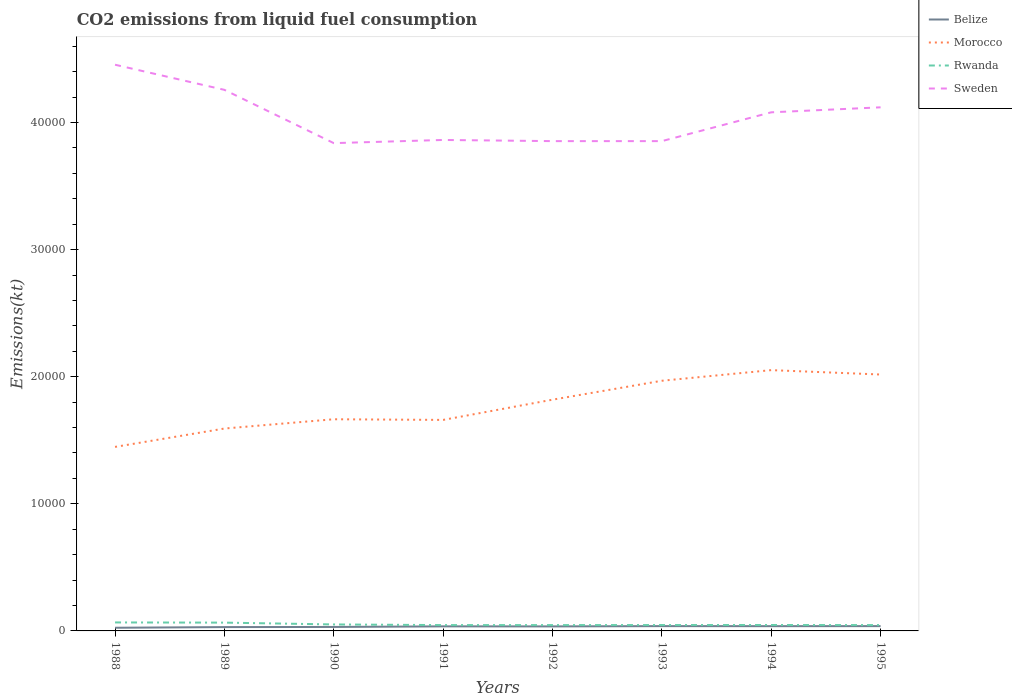How many different coloured lines are there?
Keep it short and to the point. 4. Is the number of lines equal to the number of legend labels?
Offer a very short reply. Yes. Across all years, what is the maximum amount of CO2 emitted in Morocco?
Give a very brief answer. 1.45e+04. In which year was the amount of CO2 emitted in Belize maximum?
Offer a very short reply. 1988. What is the total amount of CO2 emitted in Belize in the graph?
Keep it short and to the point. -11. What is the difference between the highest and the second highest amount of CO2 emitted in Sweden?
Ensure brevity in your answer.  6167.89. Is the amount of CO2 emitted in Morocco strictly greater than the amount of CO2 emitted in Rwanda over the years?
Offer a very short reply. No. How many lines are there?
Offer a very short reply. 4. How many years are there in the graph?
Keep it short and to the point. 8. Are the values on the major ticks of Y-axis written in scientific E-notation?
Offer a very short reply. No. Does the graph contain grids?
Ensure brevity in your answer.  No. Where does the legend appear in the graph?
Your answer should be very brief. Top right. What is the title of the graph?
Ensure brevity in your answer.  CO2 emissions from liquid fuel consumption. What is the label or title of the X-axis?
Provide a succinct answer. Years. What is the label or title of the Y-axis?
Keep it short and to the point. Emissions(kt). What is the Emissions(kt) in Belize in 1988?
Keep it short and to the point. 249.36. What is the Emissions(kt) in Morocco in 1988?
Keep it short and to the point. 1.45e+04. What is the Emissions(kt) of Rwanda in 1988?
Offer a very short reply. 667.39. What is the Emissions(kt) in Sweden in 1988?
Provide a short and direct response. 4.45e+04. What is the Emissions(kt) of Belize in 1989?
Your answer should be very brief. 300.69. What is the Emissions(kt) in Morocco in 1989?
Offer a very short reply. 1.59e+04. What is the Emissions(kt) of Rwanda in 1989?
Offer a very short reply. 652.73. What is the Emissions(kt) of Sweden in 1989?
Give a very brief answer. 4.26e+04. What is the Emissions(kt) in Belize in 1990?
Your answer should be compact. 311.69. What is the Emissions(kt) of Morocco in 1990?
Give a very brief answer. 1.67e+04. What is the Emissions(kt) of Rwanda in 1990?
Your response must be concise. 509.71. What is the Emissions(kt) in Sweden in 1990?
Make the answer very short. 3.84e+04. What is the Emissions(kt) in Belize in 1991?
Your answer should be compact. 359.37. What is the Emissions(kt) of Morocco in 1991?
Give a very brief answer. 1.66e+04. What is the Emissions(kt) of Rwanda in 1991?
Give a very brief answer. 458.38. What is the Emissions(kt) in Sweden in 1991?
Make the answer very short. 3.86e+04. What is the Emissions(kt) in Belize in 1992?
Give a very brief answer. 355.7. What is the Emissions(kt) in Morocco in 1992?
Your response must be concise. 1.82e+04. What is the Emissions(kt) in Rwanda in 1992?
Make the answer very short. 458.38. What is the Emissions(kt) of Sweden in 1992?
Your response must be concise. 3.85e+04. What is the Emissions(kt) in Belize in 1993?
Your answer should be very brief. 377.7. What is the Emissions(kt) of Morocco in 1993?
Give a very brief answer. 1.97e+04. What is the Emissions(kt) of Rwanda in 1993?
Offer a very short reply. 462.04. What is the Emissions(kt) of Sweden in 1993?
Keep it short and to the point. 3.85e+04. What is the Emissions(kt) in Belize in 1994?
Keep it short and to the point. 374.03. What is the Emissions(kt) in Morocco in 1994?
Your answer should be very brief. 2.05e+04. What is the Emissions(kt) in Rwanda in 1994?
Keep it short and to the point. 465.71. What is the Emissions(kt) in Sweden in 1994?
Ensure brevity in your answer.  4.08e+04. What is the Emissions(kt) in Belize in 1995?
Provide a short and direct response. 377.7. What is the Emissions(kt) in Morocco in 1995?
Your answer should be compact. 2.02e+04. What is the Emissions(kt) of Rwanda in 1995?
Offer a very short reply. 458.38. What is the Emissions(kt) of Sweden in 1995?
Offer a terse response. 4.12e+04. Across all years, what is the maximum Emissions(kt) of Belize?
Your answer should be compact. 377.7. Across all years, what is the maximum Emissions(kt) of Morocco?
Give a very brief answer. 2.05e+04. Across all years, what is the maximum Emissions(kt) in Rwanda?
Provide a succinct answer. 667.39. Across all years, what is the maximum Emissions(kt) in Sweden?
Keep it short and to the point. 4.45e+04. Across all years, what is the minimum Emissions(kt) in Belize?
Offer a terse response. 249.36. Across all years, what is the minimum Emissions(kt) in Morocco?
Make the answer very short. 1.45e+04. Across all years, what is the minimum Emissions(kt) of Rwanda?
Your answer should be very brief. 458.38. Across all years, what is the minimum Emissions(kt) in Sweden?
Keep it short and to the point. 3.84e+04. What is the total Emissions(kt) of Belize in the graph?
Make the answer very short. 2706.25. What is the total Emissions(kt) of Morocco in the graph?
Your answer should be compact. 1.42e+05. What is the total Emissions(kt) of Rwanda in the graph?
Keep it short and to the point. 4132.71. What is the total Emissions(kt) of Sweden in the graph?
Offer a very short reply. 3.23e+05. What is the difference between the Emissions(kt) of Belize in 1988 and that in 1989?
Keep it short and to the point. -51.34. What is the difference between the Emissions(kt) in Morocco in 1988 and that in 1989?
Provide a succinct answer. -1444.8. What is the difference between the Emissions(kt) of Rwanda in 1988 and that in 1989?
Give a very brief answer. 14.67. What is the difference between the Emissions(kt) in Sweden in 1988 and that in 1989?
Provide a succinct answer. 1976.51. What is the difference between the Emissions(kt) of Belize in 1988 and that in 1990?
Keep it short and to the point. -62.34. What is the difference between the Emissions(kt) of Morocco in 1988 and that in 1990?
Make the answer very short. -2174.53. What is the difference between the Emissions(kt) of Rwanda in 1988 and that in 1990?
Offer a very short reply. 157.68. What is the difference between the Emissions(kt) of Sweden in 1988 and that in 1990?
Offer a very short reply. 6167.89. What is the difference between the Emissions(kt) of Belize in 1988 and that in 1991?
Keep it short and to the point. -110.01. What is the difference between the Emissions(kt) in Morocco in 1988 and that in 1991?
Offer a very short reply. -2123.19. What is the difference between the Emissions(kt) of Rwanda in 1988 and that in 1991?
Your response must be concise. 209.02. What is the difference between the Emissions(kt) in Sweden in 1988 and that in 1991?
Keep it short and to the point. 5918.54. What is the difference between the Emissions(kt) in Belize in 1988 and that in 1992?
Provide a succinct answer. -106.34. What is the difference between the Emissions(kt) in Morocco in 1988 and that in 1992?
Keep it short and to the point. -3714.67. What is the difference between the Emissions(kt) in Rwanda in 1988 and that in 1992?
Your answer should be very brief. 209.02. What is the difference between the Emissions(kt) in Sweden in 1988 and that in 1992?
Provide a short and direct response. 6010.21. What is the difference between the Emissions(kt) of Belize in 1988 and that in 1993?
Your answer should be very brief. -128.34. What is the difference between the Emissions(kt) of Morocco in 1988 and that in 1993?
Give a very brief answer. -5203.47. What is the difference between the Emissions(kt) of Rwanda in 1988 and that in 1993?
Provide a short and direct response. 205.35. What is the difference between the Emissions(kt) of Sweden in 1988 and that in 1993?
Your answer should be compact. 6010.21. What is the difference between the Emissions(kt) of Belize in 1988 and that in 1994?
Your answer should be very brief. -124.68. What is the difference between the Emissions(kt) of Morocco in 1988 and that in 1994?
Provide a succinct answer. -6039.55. What is the difference between the Emissions(kt) in Rwanda in 1988 and that in 1994?
Offer a terse response. 201.69. What is the difference between the Emissions(kt) of Sweden in 1988 and that in 1994?
Provide a short and direct response. 3744.01. What is the difference between the Emissions(kt) of Belize in 1988 and that in 1995?
Provide a short and direct response. -128.34. What is the difference between the Emissions(kt) of Morocco in 1988 and that in 1995?
Your response must be concise. -5694.85. What is the difference between the Emissions(kt) in Rwanda in 1988 and that in 1995?
Keep it short and to the point. 209.02. What is the difference between the Emissions(kt) in Sweden in 1988 and that in 1995?
Offer a terse response. 3351.64. What is the difference between the Emissions(kt) of Belize in 1989 and that in 1990?
Offer a very short reply. -11. What is the difference between the Emissions(kt) of Morocco in 1989 and that in 1990?
Give a very brief answer. -729.73. What is the difference between the Emissions(kt) in Rwanda in 1989 and that in 1990?
Keep it short and to the point. 143.01. What is the difference between the Emissions(kt) in Sweden in 1989 and that in 1990?
Make the answer very short. 4191.38. What is the difference between the Emissions(kt) of Belize in 1989 and that in 1991?
Offer a very short reply. -58.67. What is the difference between the Emissions(kt) in Morocco in 1989 and that in 1991?
Offer a very short reply. -678.39. What is the difference between the Emissions(kt) of Rwanda in 1989 and that in 1991?
Make the answer very short. 194.35. What is the difference between the Emissions(kt) of Sweden in 1989 and that in 1991?
Your answer should be compact. 3942.03. What is the difference between the Emissions(kt) in Belize in 1989 and that in 1992?
Offer a terse response. -55.01. What is the difference between the Emissions(kt) of Morocco in 1989 and that in 1992?
Your answer should be very brief. -2269.87. What is the difference between the Emissions(kt) in Rwanda in 1989 and that in 1992?
Provide a succinct answer. 194.35. What is the difference between the Emissions(kt) of Sweden in 1989 and that in 1992?
Offer a very short reply. 4033.7. What is the difference between the Emissions(kt) of Belize in 1989 and that in 1993?
Make the answer very short. -77.01. What is the difference between the Emissions(kt) of Morocco in 1989 and that in 1993?
Ensure brevity in your answer.  -3758.68. What is the difference between the Emissions(kt) of Rwanda in 1989 and that in 1993?
Your answer should be very brief. 190.68. What is the difference between the Emissions(kt) in Sweden in 1989 and that in 1993?
Your answer should be very brief. 4033.7. What is the difference between the Emissions(kt) in Belize in 1989 and that in 1994?
Make the answer very short. -73.34. What is the difference between the Emissions(kt) in Morocco in 1989 and that in 1994?
Offer a terse response. -4594.75. What is the difference between the Emissions(kt) of Rwanda in 1989 and that in 1994?
Your response must be concise. 187.02. What is the difference between the Emissions(kt) of Sweden in 1989 and that in 1994?
Offer a very short reply. 1767.49. What is the difference between the Emissions(kt) in Belize in 1989 and that in 1995?
Provide a succinct answer. -77.01. What is the difference between the Emissions(kt) of Morocco in 1989 and that in 1995?
Offer a terse response. -4250.05. What is the difference between the Emissions(kt) of Rwanda in 1989 and that in 1995?
Give a very brief answer. 194.35. What is the difference between the Emissions(kt) of Sweden in 1989 and that in 1995?
Your answer should be very brief. 1375.12. What is the difference between the Emissions(kt) in Belize in 1990 and that in 1991?
Your answer should be very brief. -47.67. What is the difference between the Emissions(kt) in Morocco in 1990 and that in 1991?
Offer a very short reply. 51.34. What is the difference between the Emissions(kt) in Rwanda in 1990 and that in 1991?
Your response must be concise. 51.34. What is the difference between the Emissions(kt) in Sweden in 1990 and that in 1991?
Ensure brevity in your answer.  -249.36. What is the difference between the Emissions(kt) of Belize in 1990 and that in 1992?
Offer a very short reply. -44. What is the difference between the Emissions(kt) in Morocco in 1990 and that in 1992?
Your answer should be compact. -1540.14. What is the difference between the Emissions(kt) in Rwanda in 1990 and that in 1992?
Provide a succinct answer. 51.34. What is the difference between the Emissions(kt) of Sweden in 1990 and that in 1992?
Your response must be concise. -157.68. What is the difference between the Emissions(kt) of Belize in 1990 and that in 1993?
Your answer should be compact. -66.01. What is the difference between the Emissions(kt) of Morocco in 1990 and that in 1993?
Make the answer very short. -3028.94. What is the difference between the Emissions(kt) of Rwanda in 1990 and that in 1993?
Provide a short and direct response. 47.67. What is the difference between the Emissions(kt) in Sweden in 1990 and that in 1993?
Your response must be concise. -157.68. What is the difference between the Emissions(kt) in Belize in 1990 and that in 1994?
Provide a short and direct response. -62.34. What is the difference between the Emissions(kt) in Morocco in 1990 and that in 1994?
Give a very brief answer. -3865.02. What is the difference between the Emissions(kt) in Rwanda in 1990 and that in 1994?
Your answer should be very brief. 44. What is the difference between the Emissions(kt) in Sweden in 1990 and that in 1994?
Offer a terse response. -2423.89. What is the difference between the Emissions(kt) in Belize in 1990 and that in 1995?
Provide a succinct answer. -66.01. What is the difference between the Emissions(kt) in Morocco in 1990 and that in 1995?
Your answer should be very brief. -3520.32. What is the difference between the Emissions(kt) in Rwanda in 1990 and that in 1995?
Your answer should be compact. 51.34. What is the difference between the Emissions(kt) in Sweden in 1990 and that in 1995?
Your answer should be compact. -2816.26. What is the difference between the Emissions(kt) in Belize in 1991 and that in 1992?
Give a very brief answer. 3.67. What is the difference between the Emissions(kt) in Morocco in 1991 and that in 1992?
Provide a succinct answer. -1591.48. What is the difference between the Emissions(kt) of Rwanda in 1991 and that in 1992?
Make the answer very short. 0. What is the difference between the Emissions(kt) of Sweden in 1991 and that in 1992?
Provide a succinct answer. 91.67. What is the difference between the Emissions(kt) in Belize in 1991 and that in 1993?
Your answer should be compact. -18.34. What is the difference between the Emissions(kt) of Morocco in 1991 and that in 1993?
Make the answer very short. -3080.28. What is the difference between the Emissions(kt) of Rwanda in 1991 and that in 1993?
Offer a very short reply. -3.67. What is the difference between the Emissions(kt) in Sweden in 1991 and that in 1993?
Keep it short and to the point. 91.67. What is the difference between the Emissions(kt) in Belize in 1991 and that in 1994?
Your response must be concise. -14.67. What is the difference between the Emissions(kt) in Morocco in 1991 and that in 1994?
Give a very brief answer. -3916.36. What is the difference between the Emissions(kt) in Rwanda in 1991 and that in 1994?
Offer a very short reply. -7.33. What is the difference between the Emissions(kt) in Sweden in 1991 and that in 1994?
Offer a terse response. -2174.53. What is the difference between the Emissions(kt) in Belize in 1991 and that in 1995?
Provide a succinct answer. -18.34. What is the difference between the Emissions(kt) of Morocco in 1991 and that in 1995?
Your response must be concise. -3571.66. What is the difference between the Emissions(kt) in Rwanda in 1991 and that in 1995?
Your answer should be very brief. 0. What is the difference between the Emissions(kt) of Sweden in 1991 and that in 1995?
Provide a succinct answer. -2566.9. What is the difference between the Emissions(kt) in Belize in 1992 and that in 1993?
Give a very brief answer. -22. What is the difference between the Emissions(kt) of Morocco in 1992 and that in 1993?
Give a very brief answer. -1488.8. What is the difference between the Emissions(kt) of Rwanda in 1992 and that in 1993?
Keep it short and to the point. -3.67. What is the difference between the Emissions(kt) in Belize in 1992 and that in 1994?
Ensure brevity in your answer.  -18.34. What is the difference between the Emissions(kt) of Morocco in 1992 and that in 1994?
Provide a short and direct response. -2324.88. What is the difference between the Emissions(kt) of Rwanda in 1992 and that in 1994?
Provide a short and direct response. -7.33. What is the difference between the Emissions(kt) of Sweden in 1992 and that in 1994?
Your response must be concise. -2266.21. What is the difference between the Emissions(kt) of Belize in 1992 and that in 1995?
Make the answer very short. -22. What is the difference between the Emissions(kt) of Morocco in 1992 and that in 1995?
Offer a terse response. -1980.18. What is the difference between the Emissions(kt) in Rwanda in 1992 and that in 1995?
Your answer should be very brief. 0. What is the difference between the Emissions(kt) in Sweden in 1992 and that in 1995?
Provide a succinct answer. -2658.57. What is the difference between the Emissions(kt) of Belize in 1993 and that in 1994?
Provide a succinct answer. 3.67. What is the difference between the Emissions(kt) in Morocco in 1993 and that in 1994?
Offer a very short reply. -836.08. What is the difference between the Emissions(kt) of Rwanda in 1993 and that in 1994?
Your answer should be very brief. -3.67. What is the difference between the Emissions(kt) of Sweden in 1993 and that in 1994?
Your answer should be compact. -2266.21. What is the difference between the Emissions(kt) in Belize in 1993 and that in 1995?
Make the answer very short. 0. What is the difference between the Emissions(kt) in Morocco in 1993 and that in 1995?
Your response must be concise. -491.38. What is the difference between the Emissions(kt) in Rwanda in 1993 and that in 1995?
Keep it short and to the point. 3.67. What is the difference between the Emissions(kt) in Sweden in 1993 and that in 1995?
Your response must be concise. -2658.57. What is the difference between the Emissions(kt) of Belize in 1994 and that in 1995?
Make the answer very short. -3.67. What is the difference between the Emissions(kt) of Morocco in 1994 and that in 1995?
Offer a very short reply. 344.7. What is the difference between the Emissions(kt) in Rwanda in 1994 and that in 1995?
Offer a very short reply. 7.33. What is the difference between the Emissions(kt) in Sweden in 1994 and that in 1995?
Give a very brief answer. -392.37. What is the difference between the Emissions(kt) in Belize in 1988 and the Emissions(kt) in Morocco in 1989?
Your answer should be compact. -1.57e+04. What is the difference between the Emissions(kt) in Belize in 1988 and the Emissions(kt) in Rwanda in 1989?
Offer a terse response. -403.37. What is the difference between the Emissions(kt) in Belize in 1988 and the Emissions(kt) in Sweden in 1989?
Offer a terse response. -4.23e+04. What is the difference between the Emissions(kt) of Morocco in 1988 and the Emissions(kt) of Rwanda in 1989?
Keep it short and to the point. 1.38e+04. What is the difference between the Emissions(kt) in Morocco in 1988 and the Emissions(kt) in Sweden in 1989?
Your answer should be compact. -2.81e+04. What is the difference between the Emissions(kt) of Rwanda in 1988 and the Emissions(kt) of Sweden in 1989?
Give a very brief answer. -4.19e+04. What is the difference between the Emissions(kt) in Belize in 1988 and the Emissions(kt) in Morocco in 1990?
Your answer should be very brief. -1.64e+04. What is the difference between the Emissions(kt) of Belize in 1988 and the Emissions(kt) of Rwanda in 1990?
Keep it short and to the point. -260.36. What is the difference between the Emissions(kt) of Belize in 1988 and the Emissions(kt) of Sweden in 1990?
Keep it short and to the point. -3.81e+04. What is the difference between the Emissions(kt) in Morocco in 1988 and the Emissions(kt) in Rwanda in 1990?
Your response must be concise. 1.40e+04. What is the difference between the Emissions(kt) of Morocco in 1988 and the Emissions(kt) of Sweden in 1990?
Your answer should be compact. -2.39e+04. What is the difference between the Emissions(kt) of Rwanda in 1988 and the Emissions(kt) of Sweden in 1990?
Your answer should be compact. -3.77e+04. What is the difference between the Emissions(kt) of Belize in 1988 and the Emissions(kt) of Morocco in 1991?
Provide a short and direct response. -1.64e+04. What is the difference between the Emissions(kt) of Belize in 1988 and the Emissions(kt) of Rwanda in 1991?
Offer a very short reply. -209.02. What is the difference between the Emissions(kt) in Belize in 1988 and the Emissions(kt) in Sweden in 1991?
Offer a terse response. -3.84e+04. What is the difference between the Emissions(kt) of Morocco in 1988 and the Emissions(kt) of Rwanda in 1991?
Your response must be concise. 1.40e+04. What is the difference between the Emissions(kt) in Morocco in 1988 and the Emissions(kt) in Sweden in 1991?
Offer a very short reply. -2.41e+04. What is the difference between the Emissions(kt) of Rwanda in 1988 and the Emissions(kt) of Sweden in 1991?
Offer a terse response. -3.80e+04. What is the difference between the Emissions(kt) of Belize in 1988 and the Emissions(kt) of Morocco in 1992?
Make the answer very short. -1.79e+04. What is the difference between the Emissions(kt) of Belize in 1988 and the Emissions(kt) of Rwanda in 1992?
Give a very brief answer. -209.02. What is the difference between the Emissions(kt) of Belize in 1988 and the Emissions(kt) of Sweden in 1992?
Provide a short and direct response. -3.83e+04. What is the difference between the Emissions(kt) of Morocco in 1988 and the Emissions(kt) of Rwanda in 1992?
Your answer should be compact. 1.40e+04. What is the difference between the Emissions(kt) in Morocco in 1988 and the Emissions(kt) in Sweden in 1992?
Your answer should be compact. -2.41e+04. What is the difference between the Emissions(kt) of Rwanda in 1988 and the Emissions(kt) of Sweden in 1992?
Give a very brief answer. -3.79e+04. What is the difference between the Emissions(kt) in Belize in 1988 and the Emissions(kt) in Morocco in 1993?
Give a very brief answer. -1.94e+04. What is the difference between the Emissions(kt) of Belize in 1988 and the Emissions(kt) of Rwanda in 1993?
Offer a terse response. -212.69. What is the difference between the Emissions(kt) of Belize in 1988 and the Emissions(kt) of Sweden in 1993?
Your response must be concise. -3.83e+04. What is the difference between the Emissions(kt) of Morocco in 1988 and the Emissions(kt) of Rwanda in 1993?
Keep it short and to the point. 1.40e+04. What is the difference between the Emissions(kt) in Morocco in 1988 and the Emissions(kt) in Sweden in 1993?
Your answer should be very brief. -2.41e+04. What is the difference between the Emissions(kt) in Rwanda in 1988 and the Emissions(kt) in Sweden in 1993?
Give a very brief answer. -3.79e+04. What is the difference between the Emissions(kt) in Belize in 1988 and the Emissions(kt) in Morocco in 1994?
Offer a terse response. -2.03e+04. What is the difference between the Emissions(kt) in Belize in 1988 and the Emissions(kt) in Rwanda in 1994?
Your answer should be very brief. -216.35. What is the difference between the Emissions(kt) in Belize in 1988 and the Emissions(kt) in Sweden in 1994?
Offer a terse response. -4.05e+04. What is the difference between the Emissions(kt) in Morocco in 1988 and the Emissions(kt) in Rwanda in 1994?
Give a very brief answer. 1.40e+04. What is the difference between the Emissions(kt) of Morocco in 1988 and the Emissions(kt) of Sweden in 1994?
Your response must be concise. -2.63e+04. What is the difference between the Emissions(kt) in Rwanda in 1988 and the Emissions(kt) in Sweden in 1994?
Ensure brevity in your answer.  -4.01e+04. What is the difference between the Emissions(kt) of Belize in 1988 and the Emissions(kt) of Morocco in 1995?
Offer a very short reply. -1.99e+04. What is the difference between the Emissions(kt) of Belize in 1988 and the Emissions(kt) of Rwanda in 1995?
Your answer should be very brief. -209.02. What is the difference between the Emissions(kt) in Belize in 1988 and the Emissions(kt) in Sweden in 1995?
Offer a very short reply. -4.09e+04. What is the difference between the Emissions(kt) of Morocco in 1988 and the Emissions(kt) of Rwanda in 1995?
Your response must be concise. 1.40e+04. What is the difference between the Emissions(kt) in Morocco in 1988 and the Emissions(kt) in Sweden in 1995?
Your answer should be very brief. -2.67e+04. What is the difference between the Emissions(kt) of Rwanda in 1988 and the Emissions(kt) of Sweden in 1995?
Your answer should be compact. -4.05e+04. What is the difference between the Emissions(kt) in Belize in 1989 and the Emissions(kt) in Morocco in 1990?
Offer a very short reply. -1.64e+04. What is the difference between the Emissions(kt) of Belize in 1989 and the Emissions(kt) of Rwanda in 1990?
Provide a short and direct response. -209.02. What is the difference between the Emissions(kt) in Belize in 1989 and the Emissions(kt) in Sweden in 1990?
Offer a very short reply. -3.81e+04. What is the difference between the Emissions(kt) of Morocco in 1989 and the Emissions(kt) of Rwanda in 1990?
Your response must be concise. 1.54e+04. What is the difference between the Emissions(kt) of Morocco in 1989 and the Emissions(kt) of Sweden in 1990?
Your answer should be very brief. -2.25e+04. What is the difference between the Emissions(kt) of Rwanda in 1989 and the Emissions(kt) of Sweden in 1990?
Provide a short and direct response. -3.77e+04. What is the difference between the Emissions(kt) in Belize in 1989 and the Emissions(kt) in Morocco in 1991?
Your answer should be very brief. -1.63e+04. What is the difference between the Emissions(kt) of Belize in 1989 and the Emissions(kt) of Rwanda in 1991?
Provide a short and direct response. -157.68. What is the difference between the Emissions(kt) in Belize in 1989 and the Emissions(kt) in Sweden in 1991?
Provide a succinct answer. -3.83e+04. What is the difference between the Emissions(kt) of Morocco in 1989 and the Emissions(kt) of Rwanda in 1991?
Your response must be concise. 1.55e+04. What is the difference between the Emissions(kt) of Morocco in 1989 and the Emissions(kt) of Sweden in 1991?
Keep it short and to the point. -2.27e+04. What is the difference between the Emissions(kt) of Rwanda in 1989 and the Emissions(kt) of Sweden in 1991?
Make the answer very short. -3.80e+04. What is the difference between the Emissions(kt) in Belize in 1989 and the Emissions(kt) in Morocco in 1992?
Ensure brevity in your answer.  -1.79e+04. What is the difference between the Emissions(kt) in Belize in 1989 and the Emissions(kt) in Rwanda in 1992?
Ensure brevity in your answer.  -157.68. What is the difference between the Emissions(kt) of Belize in 1989 and the Emissions(kt) of Sweden in 1992?
Ensure brevity in your answer.  -3.82e+04. What is the difference between the Emissions(kt) in Morocco in 1989 and the Emissions(kt) in Rwanda in 1992?
Ensure brevity in your answer.  1.55e+04. What is the difference between the Emissions(kt) in Morocco in 1989 and the Emissions(kt) in Sweden in 1992?
Your answer should be compact. -2.26e+04. What is the difference between the Emissions(kt) in Rwanda in 1989 and the Emissions(kt) in Sweden in 1992?
Ensure brevity in your answer.  -3.79e+04. What is the difference between the Emissions(kt) of Belize in 1989 and the Emissions(kt) of Morocco in 1993?
Your response must be concise. -1.94e+04. What is the difference between the Emissions(kt) in Belize in 1989 and the Emissions(kt) in Rwanda in 1993?
Offer a very short reply. -161.35. What is the difference between the Emissions(kt) in Belize in 1989 and the Emissions(kt) in Sweden in 1993?
Your answer should be very brief. -3.82e+04. What is the difference between the Emissions(kt) of Morocco in 1989 and the Emissions(kt) of Rwanda in 1993?
Make the answer very short. 1.55e+04. What is the difference between the Emissions(kt) in Morocco in 1989 and the Emissions(kt) in Sweden in 1993?
Provide a short and direct response. -2.26e+04. What is the difference between the Emissions(kt) of Rwanda in 1989 and the Emissions(kt) of Sweden in 1993?
Offer a terse response. -3.79e+04. What is the difference between the Emissions(kt) in Belize in 1989 and the Emissions(kt) in Morocco in 1994?
Your answer should be compact. -2.02e+04. What is the difference between the Emissions(kt) in Belize in 1989 and the Emissions(kt) in Rwanda in 1994?
Keep it short and to the point. -165.01. What is the difference between the Emissions(kt) in Belize in 1989 and the Emissions(kt) in Sweden in 1994?
Offer a very short reply. -4.05e+04. What is the difference between the Emissions(kt) of Morocco in 1989 and the Emissions(kt) of Rwanda in 1994?
Your answer should be very brief. 1.55e+04. What is the difference between the Emissions(kt) of Morocco in 1989 and the Emissions(kt) of Sweden in 1994?
Ensure brevity in your answer.  -2.49e+04. What is the difference between the Emissions(kt) in Rwanda in 1989 and the Emissions(kt) in Sweden in 1994?
Offer a very short reply. -4.01e+04. What is the difference between the Emissions(kt) in Belize in 1989 and the Emissions(kt) in Morocco in 1995?
Provide a succinct answer. -1.99e+04. What is the difference between the Emissions(kt) of Belize in 1989 and the Emissions(kt) of Rwanda in 1995?
Give a very brief answer. -157.68. What is the difference between the Emissions(kt) of Belize in 1989 and the Emissions(kt) of Sweden in 1995?
Ensure brevity in your answer.  -4.09e+04. What is the difference between the Emissions(kt) in Morocco in 1989 and the Emissions(kt) in Rwanda in 1995?
Give a very brief answer. 1.55e+04. What is the difference between the Emissions(kt) of Morocco in 1989 and the Emissions(kt) of Sweden in 1995?
Your answer should be compact. -2.53e+04. What is the difference between the Emissions(kt) in Rwanda in 1989 and the Emissions(kt) in Sweden in 1995?
Keep it short and to the point. -4.05e+04. What is the difference between the Emissions(kt) of Belize in 1990 and the Emissions(kt) of Morocco in 1991?
Offer a very short reply. -1.63e+04. What is the difference between the Emissions(kt) of Belize in 1990 and the Emissions(kt) of Rwanda in 1991?
Provide a short and direct response. -146.68. What is the difference between the Emissions(kt) in Belize in 1990 and the Emissions(kt) in Sweden in 1991?
Your answer should be compact. -3.83e+04. What is the difference between the Emissions(kt) in Morocco in 1990 and the Emissions(kt) in Rwanda in 1991?
Offer a terse response. 1.62e+04. What is the difference between the Emissions(kt) in Morocco in 1990 and the Emissions(kt) in Sweden in 1991?
Your answer should be compact. -2.20e+04. What is the difference between the Emissions(kt) in Rwanda in 1990 and the Emissions(kt) in Sweden in 1991?
Keep it short and to the point. -3.81e+04. What is the difference between the Emissions(kt) of Belize in 1990 and the Emissions(kt) of Morocco in 1992?
Offer a very short reply. -1.79e+04. What is the difference between the Emissions(kt) in Belize in 1990 and the Emissions(kt) in Rwanda in 1992?
Provide a short and direct response. -146.68. What is the difference between the Emissions(kt) in Belize in 1990 and the Emissions(kt) in Sweden in 1992?
Ensure brevity in your answer.  -3.82e+04. What is the difference between the Emissions(kt) in Morocco in 1990 and the Emissions(kt) in Rwanda in 1992?
Offer a terse response. 1.62e+04. What is the difference between the Emissions(kt) in Morocco in 1990 and the Emissions(kt) in Sweden in 1992?
Your response must be concise. -2.19e+04. What is the difference between the Emissions(kt) of Rwanda in 1990 and the Emissions(kt) of Sweden in 1992?
Make the answer very short. -3.80e+04. What is the difference between the Emissions(kt) of Belize in 1990 and the Emissions(kt) of Morocco in 1993?
Provide a succinct answer. -1.94e+04. What is the difference between the Emissions(kt) of Belize in 1990 and the Emissions(kt) of Rwanda in 1993?
Your answer should be compact. -150.35. What is the difference between the Emissions(kt) of Belize in 1990 and the Emissions(kt) of Sweden in 1993?
Offer a very short reply. -3.82e+04. What is the difference between the Emissions(kt) of Morocco in 1990 and the Emissions(kt) of Rwanda in 1993?
Your answer should be very brief. 1.62e+04. What is the difference between the Emissions(kt) in Morocco in 1990 and the Emissions(kt) in Sweden in 1993?
Offer a very short reply. -2.19e+04. What is the difference between the Emissions(kt) of Rwanda in 1990 and the Emissions(kt) of Sweden in 1993?
Provide a succinct answer. -3.80e+04. What is the difference between the Emissions(kt) in Belize in 1990 and the Emissions(kt) in Morocco in 1994?
Provide a succinct answer. -2.02e+04. What is the difference between the Emissions(kt) in Belize in 1990 and the Emissions(kt) in Rwanda in 1994?
Provide a short and direct response. -154.01. What is the difference between the Emissions(kt) in Belize in 1990 and the Emissions(kt) in Sweden in 1994?
Provide a succinct answer. -4.05e+04. What is the difference between the Emissions(kt) in Morocco in 1990 and the Emissions(kt) in Rwanda in 1994?
Your answer should be very brief. 1.62e+04. What is the difference between the Emissions(kt) in Morocco in 1990 and the Emissions(kt) in Sweden in 1994?
Keep it short and to the point. -2.41e+04. What is the difference between the Emissions(kt) in Rwanda in 1990 and the Emissions(kt) in Sweden in 1994?
Provide a succinct answer. -4.03e+04. What is the difference between the Emissions(kt) of Belize in 1990 and the Emissions(kt) of Morocco in 1995?
Provide a short and direct response. -1.99e+04. What is the difference between the Emissions(kt) of Belize in 1990 and the Emissions(kt) of Rwanda in 1995?
Make the answer very short. -146.68. What is the difference between the Emissions(kt) of Belize in 1990 and the Emissions(kt) of Sweden in 1995?
Your response must be concise. -4.09e+04. What is the difference between the Emissions(kt) in Morocco in 1990 and the Emissions(kt) in Rwanda in 1995?
Keep it short and to the point. 1.62e+04. What is the difference between the Emissions(kt) of Morocco in 1990 and the Emissions(kt) of Sweden in 1995?
Your response must be concise. -2.45e+04. What is the difference between the Emissions(kt) of Rwanda in 1990 and the Emissions(kt) of Sweden in 1995?
Give a very brief answer. -4.07e+04. What is the difference between the Emissions(kt) in Belize in 1991 and the Emissions(kt) in Morocco in 1992?
Make the answer very short. -1.78e+04. What is the difference between the Emissions(kt) of Belize in 1991 and the Emissions(kt) of Rwanda in 1992?
Give a very brief answer. -99.01. What is the difference between the Emissions(kt) of Belize in 1991 and the Emissions(kt) of Sweden in 1992?
Give a very brief answer. -3.82e+04. What is the difference between the Emissions(kt) in Morocco in 1991 and the Emissions(kt) in Rwanda in 1992?
Your response must be concise. 1.61e+04. What is the difference between the Emissions(kt) of Morocco in 1991 and the Emissions(kt) of Sweden in 1992?
Provide a short and direct response. -2.19e+04. What is the difference between the Emissions(kt) in Rwanda in 1991 and the Emissions(kt) in Sweden in 1992?
Give a very brief answer. -3.81e+04. What is the difference between the Emissions(kt) in Belize in 1991 and the Emissions(kt) in Morocco in 1993?
Your answer should be compact. -1.93e+04. What is the difference between the Emissions(kt) in Belize in 1991 and the Emissions(kt) in Rwanda in 1993?
Keep it short and to the point. -102.68. What is the difference between the Emissions(kt) of Belize in 1991 and the Emissions(kt) of Sweden in 1993?
Ensure brevity in your answer.  -3.82e+04. What is the difference between the Emissions(kt) in Morocco in 1991 and the Emissions(kt) in Rwanda in 1993?
Your answer should be very brief. 1.61e+04. What is the difference between the Emissions(kt) of Morocco in 1991 and the Emissions(kt) of Sweden in 1993?
Offer a very short reply. -2.19e+04. What is the difference between the Emissions(kt) in Rwanda in 1991 and the Emissions(kt) in Sweden in 1993?
Offer a terse response. -3.81e+04. What is the difference between the Emissions(kt) in Belize in 1991 and the Emissions(kt) in Morocco in 1994?
Your answer should be compact. -2.02e+04. What is the difference between the Emissions(kt) in Belize in 1991 and the Emissions(kt) in Rwanda in 1994?
Give a very brief answer. -106.34. What is the difference between the Emissions(kt) in Belize in 1991 and the Emissions(kt) in Sweden in 1994?
Your answer should be very brief. -4.04e+04. What is the difference between the Emissions(kt) in Morocco in 1991 and the Emissions(kt) in Rwanda in 1994?
Offer a very short reply. 1.61e+04. What is the difference between the Emissions(kt) in Morocco in 1991 and the Emissions(kt) in Sweden in 1994?
Your response must be concise. -2.42e+04. What is the difference between the Emissions(kt) in Rwanda in 1991 and the Emissions(kt) in Sweden in 1994?
Make the answer very short. -4.03e+04. What is the difference between the Emissions(kt) in Belize in 1991 and the Emissions(kt) in Morocco in 1995?
Your response must be concise. -1.98e+04. What is the difference between the Emissions(kt) of Belize in 1991 and the Emissions(kt) of Rwanda in 1995?
Give a very brief answer. -99.01. What is the difference between the Emissions(kt) in Belize in 1991 and the Emissions(kt) in Sweden in 1995?
Your answer should be compact. -4.08e+04. What is the difference between the Emissions(kt) in Morocco in 1991 and the Emissions(kt) in Rwanda in 1995?
Provide a succinct answer. 1.61e+04. What is the difference between the Emissions(kt) in Morocco in 1991 and the Emissions(kt) in Sweden in 1995?
Make the answer very short. -2.46e+04. What is the difference between the Emissions(kt) in Rwanda in 1991 and the Emissions(kt) in Sweden in 1995?
Your response must be concise. -4.07e+04. What is the difference between the Emissions(kt) of Belize in 1992 and the Emissions(kt) of Morocco in 1993?
Your answer should be compact. -1.93e+04. What is the difference between the Emissions(kt) in Belize in 1992 and the Emissions(kt) in Rwanda in 1993?
Offer a very short reply. -106.34. What is the difference between the Emissions(kt) of Belize in 1992 and the Emissions(kt) of Sweden in 1993?
Your response must be concise. -3.82e+04. What is the difference between the Emissions(kt) in Morocco in 1992 and the Emissions(kt) in Rwanda in 1993?
Provide a succinct answer. 1.77e+04. What is the difference between the Emissions(kt) of Morocco in 1992 and the Emissions(kt) of Sweden in 1993?
Provide a succinct answer. -2.03e+04. What is the difference between the Emissions(kt) in Rwanda in 1992 and the Emissions(kt) in Sweden in 1993?
Make the answer very short. -3.81e+04. What is the difference between the Emissions(kt) in Belize in 1992 and the Emissions(kt) in Morocco in 1994?
Keep it short and to the point. -2.02e+04. What is the difference between the Emissions(kt) in Belize in 1992 and the Emissions(kt) in Rwanda in 1994?
Ensure brevity in your answer.  -110.01. What is the difference between the Emissions(kt) in Belize in 1992 and the Emissions(kt) in Sweden in 1994?
Offer a very short reply. -4.04e+04. What is the difference between the Emissions(kt) of Morocco in 1992 and the Emissions(kt) of Rwanda in 1994?
Ensure brevity in your answer.  1.77e+04. What is the difference between the Emissions(kt) of Morocco in 1992 and the Emissions(kt) of Sweden in 1994?
Keep it short and to the point. -2.26e+04. What is the difference between the Emissions(kt) of Rwanda in 1992 and the Emissions(kt) of Sweden in 1994?
Offer a terse response. -4.03e+04. What is the difference between the Emissions(kt) in Belize in 1992 and the Emissions(kt) in Morocco in 1995?
Your response must be concise. -1.98e+04. What is the difference between the Emissions(kt) of Belize in 1992 and the Emissions(kt) of Rwanda in 1995?
Offer a very short reply. -102.68. What is the difference between the Emissions(kt) in Belize in 1992 and the Emissions(kt) in Sweden in 1995?
Your answer should be very brief. -4.08e+04. What is the difference between the Emissions(kt) of Morocco in 1992 and the Emissions(kt) of Rwanda in 1995?
Offer a very short reply. 1.77e+04. What is the difference between the Emissions(kt) of Morocco in 1992 and the Emissions(kt) of Sweden in 1995?
Keep it short and to the point. -2.30e+04. What is the difference between the Emissions(kt) in Rwanda in 1992 and the Emissions(kt) in Sweden in 1995?
Your answer should be compact. -4.07e+04. What is the difference between the Emissions(kt) in Belize in 1993 and the Emissions(kt) in Morocco in 1994?
Offer a terse response. -2.01e+04. What is the difference between the Emissions(kt) in Belize in 1993 and the Emissions(kt) in Rwanda in 1994?
Your answer should be very brief. -88.01. What is the difference between the Emissions(kt) in Belize in 1993 and the Emissions(kt) in Sweden in 1994?
Offer a terse response. -4.04e+04. What is the difference between the Emissions(kt) in Morocco in 1993 and the Emissions(kt) in Rwanda in 1994?
Offer a very short reply. 1.92e+04. What is the difference between the Emissions(kt) in Morocco in 1993 and the Emissions(kt) in Sweden in 1994?
Offer a very short reply. -2.11e+04. What is the difference between the Emissions(kt) in Rwanda in 1993 and the Emissions(kt) in Sweden in 1994?
Keep it short and to the point. -4.03e+04. What is the difference between the Emissions(kt) of Belize in 1993 and the Emissions(kt) of Morocco in 1995?
Your answer should be compact. -1.98e+04. What is the difference between the Emissions(kt) of Belize in 1993 and the Emissions(kt) of Rwanda in 1995?
Provide a succinct answer. -80.67. What is the difference between the Emissions(kt) of Belize in 1993 and the Emissions(kt) of Sweden in 1995?
Provide a succinct answer. -4.08e+04. What is the difference between the Emissions(kt) of Morocco in 1993 and the Emissions(kt) of Rwanda in 1995?
Your answer should be compact. 1.92e+04. What is the difference between the Emissions(kt) in Morocco in 1993 and the Emissions(kt) in Sweden in 1995?
Your answer should be very brief. -2.15e+04. What is the difference between the Emissions(kt) of Rwanda in 1993 and the Emissions(kt) of Sweden in 1995?
Give a very brief answer. -4.07e+04. What is the difference between the Emissions(kt) in Belize in 1994 and the Emissions(kt) in Morocco in 1995?
Offer a terse response. -1.98e+04. What is the difference between the Emissions(kt) of Belize in 1994 and the Emissions(kt) of Rwanda in 1995?
Give a very brief answer. -84.34. What is the difference between the Emissions(kt) in Belize in 1994 and the Emissions(kt) in Sweden in 1995?
Provide a succinct answer. -4.08e+04. What is the difference between the Emissions(kt) in Morocco in 1994 and the Emissions(kt) in Rwanda in 1995?
Offer a very short reply. 2.01e+04. What is the difference between the Emissions(kt) of Morocco in 1994 and the Emissions(kt) of Sweden in 1995?
Provide a succinct answer. -2.07e+04. What is the difference between the Emissions(kt) of Rwanda in 1994 and the Emissions(kt) of Sweden in 1995?
Provide a short and direct response. -4.07e+04. What is the average Emissions(kt) in Belize per year?
Keep it short and to the point. 338.28. What is the average Emissions(kt) in Morocco per year?
Offer a very short reply. 1.78e+04. What is the average Emissions(kt) of Rwanda per year?
Your response must be concise. 516.59. What is the average Emissions(kt) of Sweden per year?
Offer a very short reply. 4.04e+04. In the year 1988, what is the difference between the Emissions(kt) in Belize and Emissions(kt) in Morocco?
Your answer should be very brief. -1.42e+04. In the year 1988, what is the difference between the Emissions(kt) of Belize and Emissions(kt) of Rwanda?
Offer a terse response. -418.04. In the year 1988, what is the difference between the Emissions(kt) in Belize and Emissions(kt) in Sweden?
Your response must be concise. -4.43e+04. In the year 1988, what is the difference between the Emissions(kt) in Morocco and Emissions(kt) in Rwanda?
Offer a very short reply. 1.38e+04. In the year 1988, what is the difference between the Emissions(kt) of Morocco and Emissions(kt) of Sweden?
Your answer should be very brief. -3.01e+04. In the year 1988, what is the difference between the Emissions(kt) of Rwanda and Emissions(kt) of Sweden?
Your response must be concise. -4.39e+04. In the year 1989, what is the difference between the Emissions(kt) in Belize and Emissions(kt) in Morocco?
Keep it short and to the point. -1.56e+04. In the year 1989, what is the difference between the Emissions(kt) in Belize and Emissions(kt) in Rwanda?
Keep it short and to the point. -352.03. In the year 1989, what is the difference between the Emissions(kt) of Belize and Emissions(kt) of Sweden?
Offer a terse response. -4.23e+04. In the year 1989, what is the difference between the Emissions(kt) in Morocco and Emissions(kt) in Rwanda?
Offer a very short reply. 1.53e+04. In the year 1989, what is the difference between the Emissions(kt) in Morocco and Emissions(kt) in Sweden?
Your answer should be very brief. -2.66e+04. In the year 1989, what is the difference between the Emissions(kt) in Rwanda and Emissions(kt) in Sweden?
Your answer should be compact. -4.19e+04. In the year 1990, what is the difference between the Emissions(kt) in Belize and Emissions(kt) in Morocco?
Make the answer very short. -1.63e+04. In the year 1990, what is the difference between the Emissions(kt) in Belize and Emissions(kt) in Rwanda?
Your response must be concise. -198.02. In the year 1990, what is the difference between the Emissions(kt) in Belize and Emissions(kt) in Sweden?
Make the answer very short. -3.81e+04. In the year 1990, what is the difference between the Emissions(kt) in Morocco and Emissions(kt) in Rwanda?
Your response must be concise. 1.61e+04. In the year 1990, what is the difference between the Emissions(kt) in Morocco and Emissions(kt) in Sweden?
Your answer should be compact. -2.17e+04. In the year 1990, what is the difference between the Emissions(kt) of Rwanda and Emissions(kt) of Sweden?
Your answer should be compact. -3.79e+04. In the year 1991, what is the difference between the Emissions(kt) of Belize and Emissions(kt) of Morocco?
Your answer should be very brief. -1.62e+04. In the year 1991, what is the difference between the Emissions(kt) of Belize and Emissions(kt) of Rwanda?
Provide a short and direct response. -99.01. In the year 1991, what is the difference between the Emissions(kt) in Belize and Emissions(kt) in Sweden?
Make the answer very short. -3.83e+04. In the year 1991, what is the difference between the Emissions(kt) of Morocco and Emissions(kt) of Rwanda?
Your response must be concise. 1.61e+04. In the year 1991, what is the difference between the Emissions(kt) in Morocco and Emissions(kt) in Sweden?
Your response must be concise. -2.20e+04. In the year 1991, what is the difference between the Emissions(kt) of Rwanda and Emissions(kt) of Sweden?
Make the answer very short. -3.82e+04. In the year 1992, what is the difference between the Emissions(kt) of Belize and Emissions(kt) of Morocco?
Make the answer very short. -1.78e+04. In the year 1992, what is the difference between the Emissions(kt) in Belize and Emissions(kt) in Rwanda?
Offer a terse response. -102.68. In the year 1992, what is the difference between the Emissions(kt) of Belize and Emissions(kt) of Sweden?
Give a very brief answer. -3.82e+04. In the year 1992, what is the difference between the Emissions(kt) of Morocco and Emissions(kt) of Rwanda?
Give a very brief answer. 1.77e+04. In the year 1992, what is the difference between the Emissions(kt) in Morocco and Emissions(kt) in Sweden?
Your answer should be very brief. -2.03e+04. In the year 1992, what is the difference between the Emissions(kt) of Rwanda and Emissions(kt) of Sweden?
Your answer should be compact. -3.81e+04. In the year 1993, what is the difference between the Emissions(kt) of Belize and Emissions(kt) of Morocco?
Provide a succinct answer. -1.93e+04. In the year 1993, what is the difference between the Emissions(kt) of Belize and Emissions(kt) of Rwanda?
Offer a very short reply. -84.34. In the year 1993, what is the difference between the Emissions(kt) of Belize and Emissions(kt) of Sweden?
Make the answer very short. -3.82e+04. In the year 1993, what is the difference between the Emissions(kt) of Morocco and Emissions(kt) of Rwanda?
Ensure brevity in your answer.  1.92e+04. In the year 1993, what is the difference between the Emissions(kt) of Morocco and Emissions(kt) of Sweden?
Your answer should be compact. -1.89e+04. In the year 1993, what is the difference between the Emissions(kt) of Rwanda and Emissions(kt) of Sweden?
Provide a succinct answer. -3.81e+04. In the year 1994, what is the difference between the Emissions(kt) of Belize and Emissions(kt) of Morocco?
Offer a very short reply. -2.01e+04. In the year 1994, what is the difference between the Emissions(kt) of Belize and Emissions(kt) of Rwanda?
Provide a succinct answer. -91.67. In the year 1994, what is the difference between the Emissions(kt) of Belize and Emissions(kt) of Sweden?
Make the answer very short. -4.04e+04. In the year 1994, what is the difference between the Emissions(kt) of Morocco and Emissions(kt) of Rwanda?
Your response must be concise. 2.01e+04. In the year 1994, what is the difference between the Emissions(kt) of Morocco and Emissions(kt) of Sweden?
Your response must be concise. -2.03e+04. In the year 1994, what is the difference between the Emissions(kt) of Rwanda and Emissions(kt) of Sweden?
Provide a succinct answer. -4.03e+04. In the year 1995, what is the difference between the Emissions(kt) in Belize and Emissions(kt) in Morocco?
Give a very brief answer. -1.98e+04. In the year 1995, what is the difference between the Emissions(kt) of Belize and Emissions(kt) of Rwanda?
Offer a very short reply. -80.67. In the year 1995, what is the difference between the Emissions(kt) in Belize and Emissions(kt) in Sweden?
Offer a terse response. -4.08e+04. In the year 1995, what is the difference between the Emissions(kt) in Morocco and Emissions(kt) in Rwanda?
Offer a terse response. 1.97e+04. In the year 1995, what is the difference between the Emissions(kt) in Morocco and Emissions(kt) in Sweden?
Your answer should be very brief. -2.10e+04. In the year 1995, what is the difference between the Emissions(kt) of Rwanda and Emissions(kt) of Sweden?
Provide a succinct answer. -4.07e+04. What is the ratio of the Emissions(kt) in Belize in 1988 to that in 1989?
Your response must be concise. 0.83. What is the ratio of the Emissions(kt) in Morocco in 1988 to that in 1989?
Ensure brevity in your answer.  0.91. What is the ratio of the Emissions(kt) of Rwanda in 1988 to that in 1989?
Your answer should be compact. 1.02. What is the ratio of the Emissions(kt) in Sweden in 1988 to that in 1989?
Provide a succinct answer. 1.05. What is the ratio of the Emissions(kt) of Belize in 1988 to that in 1990?
Make the answer very short. 0.8. What is the ratio of the Emissions(kt) of Morocco in 1988 to that in 1990?
Your answer should be very brief. 0.87. What is the ratio of the Emissions(kt) of Rwanda in 1988 to that in 1990?
Ensure brevity in your answer.  1.31. What is the ratio of the Emissions(kt) of Sweden in 1988 to that in 1990?
Provide a succinct answer. 1.16. What is the ratio of the Emissions(kt) of Belize in 1988 to that in 1991?
Ensure brevity in your answer.  0.69. What is the ratio of the Emissions(kt) in Morocco in 1988 to that in 1991?
Give a very brief answer. 0.87. What is the ratio of the Emissions(kt) of Rwanda in 1988 to that in 1991?
Ensure brevity in your answer.  1.46. What is the ratio of the Emissions(kt) in Sweden in 1988 to that in 1991?
Offer a terse response. 1.15. What is the ratio of the Emissions(kt) in Belize in 1988 to that in 1992?
Offer a very short reply. 0.7. What is the ratio of the Emissions(kt) of Morocco in 1988 to that in 1992?
Make the answer very short. 0.8. What is the ratio of the Emissions(kt) of Rwanda in 1988 to that in 1992?
Ensure brevity in your answer.  1.46. What is the ratio of the Emissions(kt) in Sweden in 1988 to that in 1992?
Keep it short and to the point. 1.16. What is the ratio of the Emissions(kt) of Belize in 1988 to that in 1993?
Provide a succinct answer. 0.66. What is the ratio of the Emissions(kt) of Morocco in 1988 to that in 1993?
Provide a short and direct response. 0.74. What is the ratio of the Emissions(kt) of Rwanda in 1988 to that in 1993?
Offer a very short reply. 1.44. What is the ratio of the Emissions(kt) in Sweden in 1988 to that in 1993?
Offer a terse response. 1.16. What is the ratio of the Emissions(kt) of Belize in 1988 to that in 1994?
Ensure brevity in your answer.  0.67. What is the ratio of the Emissions(kt) of Morocco in 1988 to that in 1994?
Your answer should be very brief. 0.71. What is the ratio of the Emissions(kt) in Rwanda in 1988 to that in 1994?
Offer a very short reply. 1.43. What is the ratio of the Emissions(kt) of Sweden in 1988 to that in 1994?
Make the answer very short. 1.09. What is the ratio of the Emissions(kt) of Belize in 1988 to that in 1995?
Ensure brevity in your answer.  0.66. What is the ratio of the Emissions(kt) of Morocco in 1988 to that in 1995?
Give a very brief answer. 0.72. What is the ratio of the Emissions(kt) of Rwanda in 1988 to that in 1995?
Ensure brevity in your answer.  1.46. What is the ratio of the Emissions(kt) in Sweden in 1988 to that in 1995?
Offer a very short reply. 1.08. What is the ratio of the Emissions(kt) of Belize in 1989 to that in 1990?
Make the answer very short. 0.96. What is the ratio of the Emissions(kt) in Morocco in 1989 to that in 1990?
Provide a short and direct response. 0.96. What is the ratio of the Emissions(kt) in Rwanda in 1989 to that in 1990?
Give a very brief answer. 1.28. What is the ratio of the Emissions(kt) of Sweden in 1989 to that in 1990?
Give a very brief answer. 1.11. What is the ratio of the Emissions(kt) in Belize in 1989 to that in 1991?
Your answer should be very brief. 0.84. What is the ratio of the Emissions(kt) in Morocco in 1989 to that in 1991?
Your answer should be very brief. 0.96. What is the ratio of the Emissions(kt) in Rwanda in 1989 to that in 1991?
Offer a very short reply. 1.42. What is the ratio of the Emissions(kt) of Sweden in 1989 to that in 1991?
Give a very brief answer. 1.1. What is the ratio of the Emissions(kt) of Belize in 1989 to that in 1992?
Ensure brevity in your answer.  0.85. What is the ratio of the Emissions(kt) in Morocco in 1989 to that in 1992?
Offer a terse response. 0.88. What is the ratio of the Emissions(kt) of Rwanda in 1989 to that in 1992?
Your answer should be compact. 1.42. What is the ratio of the Emissions(kt) in Sweden in 1989 to that in 1992?
Make the answer very short. 1.1. What is the ratio of the Emissions(kt) in Belize in 1989 to that in 1993?
Give a very brief answer. 0.8. What is the ratio of the Emissions(kt) of Morocco in 1989 to that in 1993?
Keep it short and to the point. 0.81. What is the ratio of the Emissions(kt) of Rwanda in 1989 to that in 1993?
Your answer should be compact. 1.41. What is the ratio of the Emissions(kt) of Sweden in 1989 to that in 1993?
Offer a very short reply. 1.1. What is the ratio of the Emissions(kt) in Belize in 1989 to that in 1994?
Your response must be concise. 0.8. What is the ratio of the Emissions(kt) of Morocco in 1989 to that in 1994?
Provide a short and direct response. 0.78. What is the ratio of the Emissions(kt) in Rwanda in 1989 to that in 1994?
Your answer should be compact. 1.4. What is the ratio of the Emissions(kt) in Sweden in 1989 to that in 1994?
Provide a succinct answer. 1.04. What is the ratio of the Emissions(kt) in Belize in 1989 to that in 1995?
Offer a terse response. 0.8. What is the ratio of the Emissions(kt) of Morocco in 1989 to that in 1995?
Provide a short and direct response. 0.79. What is the ratio of the Emissions(kt) of Rwanda in 1989 to that in 1995?
Your answer should be compact. 1.42. What is the ratio of the Emissions(kt) of Sweden in 1989 to that in 1995?
Make the answer very short. 1.03. What is the ratio of the Emissions(kt) of Belize in 1990 to that in 1991?
Offer a terse response. 0.87. What is the ratio of the Emissions(kt) in Morocco in 1990 to that in 1991?
Keep it short and to the point. 1. What is the ratio of the Emissions(kt) of Rwanda in 1990 to that in 1991?
Your answer should be very brief. 1.11. What is the ratio of the Emissions(kt) of Sweden in 1990 to that in 1991?
Offer a terse response. 0.99. What is the ratio of the Emissions(kt) in Belize in 1990 to that in 1992?
Offer a terse response. 0.88. What is the ratio of the Emissions(kt) in Morocco in 1990 to that in 1992?
Ensure brevity in your answer.  0.92. What is the ratio of the Emissions(kt) of Rwanda in 1990 to that in 1992?
Provide a succinct answer. 1.11. What is the ratio of the Emissions(kt) in Sweden in 1990 to that in 1992?
Provide a short and direct response. 1. What is the ratio of the Emissions(kt) in Belize in 1990 to that in 1993?
Make the answer very short. 0.83. What is the ratio of the Emissions(kt) of Morocco in 1990 to that in 1993?
Offer a very short reply. 0.85. What is the ratio of the Emissions(kt) of Rwanda in 1990 to that in 1993?
Offer a very short reply. 1.1. What is the ratio of the Emissions(kt) in Sweden in 1990 to that in 1993?
Provide a succinct answer. 1. What is the ratio of the Emissions(kt) in Belize in 1990 to that in 1994?
Provide a succinct answer. 0.83. What is the ratio of the Emissions(kt) of Morocco in 1990 to that in 1994?
Provide a succinct answer. 0.81. What is the ratio of the Emissions(kt) of Rwanda in 1990 to that in 1994?
Your response must be concise. 1.09. What is the ratio of the Emissions(kt) of Sweden in 1990 to that in 1994?
Offer a very short reply. 0.94. What is the ratio of the Emissions(kt) in Belize in 1990 to that in 1995?
Ensure brevity in your answer.  0.83. What is the ratio of the Emissions(kt) in Morocco in 1990 to that in 1995?
Make the answer very short. 0.83. What is the ratio of the Emissions(kt) in Rwanda in 1990 to that in 1995?
Offer a terse response. 1.11. What is the ratio of the Emissions(kt) in Sweden in 1990 to that in 1995?
Give a very brief answer. 0.93. What is the ratio of the Emissions(kt) in Belize in 1991 to that in 1992?
Your answer should be compact. 1.01. What is the ratio of the Emissions(kt) of Morocco in 1991 to that in 1992?
Offer a terse response. 0.91. What is the ratio of the Emissions(kt) of Rwanda in 1991 to that in 1992?
Provide a short and direct response. 1. What is the ratio of the Emissions(kt) in Sweden in 1991 to that in 1992?
Keep it short and to the point. 1. What is the ratio of the Emissions(kt) in Belize in 1991 to that in 1993?
Offer a terse response. 0.95. What is the ratio of the Emissions(kt) of Morocco in 1991 to that in 1993?
Your answer should be compact. 0.84. What is the ratio of the Emissions(kt) in Sweden in 1991 to that in 1993?
Your answer should be compact. 1. What is the ratio of the Emissions(kt) in Belize in 1991 to that in 1994?
Provide a succinct answer. 0.96. What is the ratio of the Emissions(kt) of Morocco in 1991 to that in 1994?
Give a very brief answer. 0.81. What is the ratio of the Emissions(kt) in Rwanda in 1991 to that in 1994?
Make the answer very short. 0.98. What is the ratio of the Emissions(kt) of Sweden in 1991 to that in 1994?
Offer a very short reply. 0.95. What is the ratio of the Emissions(kt) in Belize in 1991 to that in 1995?
Your answer should be very brief. 0.95. What is the ratio of the Emissions(kt) of Morocco in 1991 to that in 1995?
Provide a short and direct response. 0.82. What is the ratio of the Emissions(kt) in Rwanda in 1991 to that in 1995?
Offer a terse response. 1. What is the ratio of the Emissions(kt) in Sweden in 1991 to that in 1995?
Your response must be concise. 0.94. What is the ratio of the Emissions(kt) of Belize in 1992 to that in 1993?
Your answer should be compact. 0.94. What is the ratio of the Emissions(kt) of Morocco in 1992 to that in 1993?
Give a very brief answer. 0.92. What is the ratio of the Emissions(kt) of Rwanda in 1992 to that in 1993?
Your answer should be very brief. 0.99. What is the ratio of the Emissions(kt) of Sweden in 1992 to that in 1993?
Ensure brevity in your answer.  1. What is the ratio of the Emissions(kt) of Belize in 1992 to that in 1994?
Offer a very short reply. 0.95. What is the ratio of the Emissions(kt) of Morocco in 1992 to that in 1994?
Ensure brevity in your answer.  0.89. What is the ratio of the Emissions(kt) of Rwanda in 1992 to that in 1994?
Offer a very short reply. 0.98. What is the ratio of the Emissions(kt) in Sweden in 1992 to that in 1994?
Give a very brief answer. 0.94. What is the ratio of the Emissions(kt) of Belize in 1992 to that in 1995?
Make the answer very short. 0.94. What is the ratio of the Emissions(kt) of Morocco in 1992 to that in 1995?
Offer a terse response. 0.9. What is the ratio of the Emissions(kt) in Sweden in 1992 to that in 1995?
Your answer should be compact. 0.94. What is the ratio of the Emissions(kt) in Belize in 1993 to that in 1994?
Give a very brief answer. 1.01. What is the ratio of the Emissions(kt) of Morocco in 1993 to that in 1994?
Offer a terse response. 0.96. What is the ratio of the Emissions(kt) in Sweden in 1993 to that in 1994?
Provide a succinct answer. 0.94. What is the ratio of the Emissions(kt) in Morocco in 1993 to that in 1995?
Provide a succinct answer. 0.98. What is the ratio of the Emissions(kt) of Rwanda in 1993 to that in 1995?
Your answer should be compact. 1.01. What is the ratio of the Emissions(kt) in Sweden in 1993 to that in 1995?
Make the answer very short. 0.94. What is the ratio of the Emissions(kt) in Belize in 1994 to that in 1995?
Offer a very short reply. 0.99. What is the ratio of the Emissions(kt) of Morocco in 1994 to that in 1995?
Provide a short and direct response. 1.02. What is the ratio of the Emissions(kt) of Rwanda in 1994 to that in 1995?
Offer a terse response. 1.02. What is the difference between the highest and the second highest Emissions(kt) in Morocco?
Give a very brief answer. 344.7. What is the difference between the highest and the second highest Emissions(kt) of Rwanda?
Give a very brief answer. 14.67. What is the difference between the highest and the second highest Emissions(kt) in Sweden?
Your response must be concise. 1976.51. What is the difference between the highest and the lowest Emissions(kt) in Belize?
Offer a very short reply. 128.34. What is the difference between the highest and the lowest Emissions(kt) of Morocco?
Your answer should be compact. 6039.55. What is the difference between the highest and the lowest Emissions(kt) in Rwanda?
Provide a succinct answer. 209.02. What is the difference between the highest and the lowest Emissions(kt) in Sweden?
Offer a very short reply. 6167.89. 